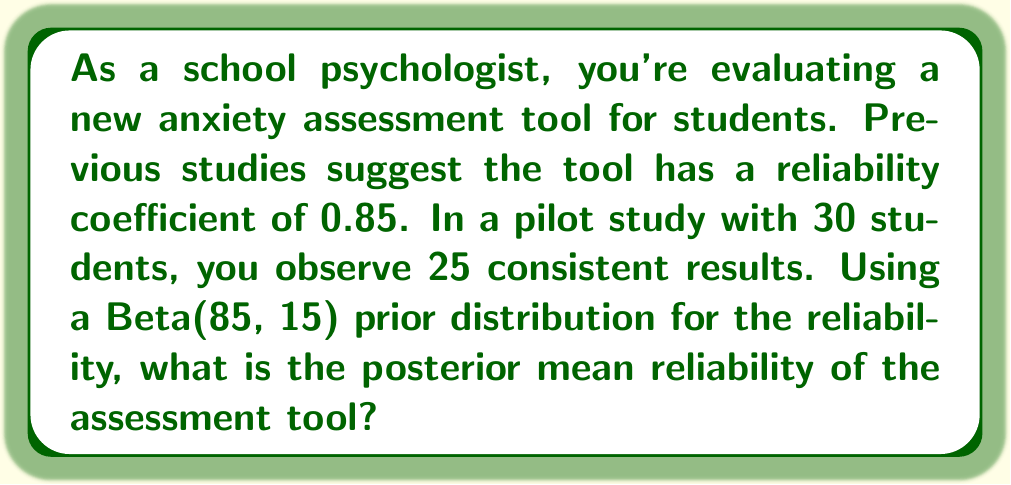Could you help me with this problem? To solve this problem, we'll use Bayesian inference with a Beta distribution as the prior and posterior.

1) The Beta distribution is conjugate to the Binomial likelihood, making it a convenient choice for reliability estimation.

2) Our prior is Beta(85, 15), which encodes our prior belief that the reliability is around 0.85.

3) In our sample of 30 students, we observed 25 consistent results. This can be modeled as a Binomial distribution.

4) The posterior distribution is also a Beta distribution. The parameters of the posterior Beta are calculated as:

   $\alpha_{posterior} = \alpha_{prior} + \text{number of successes}$
   $\beta_{posterior} = \beta_{prior} + \text{number of failures}$

5) In this case:
   $\alpha_{posterior} = 85 + 25 = 110$
   $\beta_{posterior} = 15 + (30 - 25) = 20$

6) The posterior distribution is thus Beta(110, 20).

7) The mean of a Beta(a, b) distribution is given by:

   $$\text{E}[X] = \frac{a}{a + b}$$

8) Therefore, the posterior mean reliability is:

   $$\text{E}[X] = \frac{110}{110 + 20} = \frac{110}{130} \approx 0.8462$$
Answer: The posterior mean reliability of the assessment tool is approximately 0.8462. 